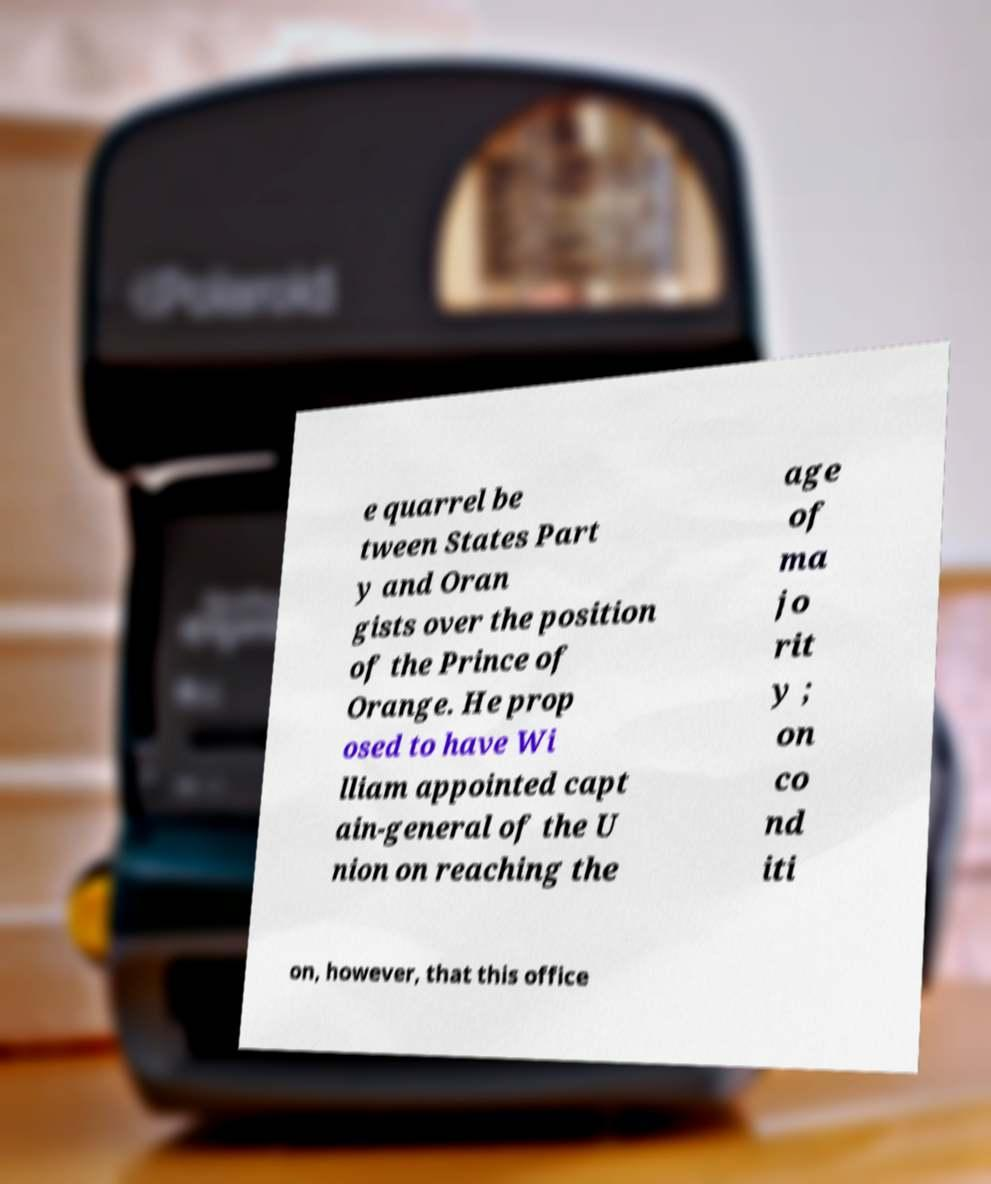There's text embedded in this image that I need extracted. Can you transcribe it verbatim? e quarrel be tween States Part y and Oran gists over the position of the Prince of Orange. He prop osed to have Wi lliam appointed capt ain-general of the U nion on reaching the age of ma jo rit y ; on co nd iti on, however, that this office 